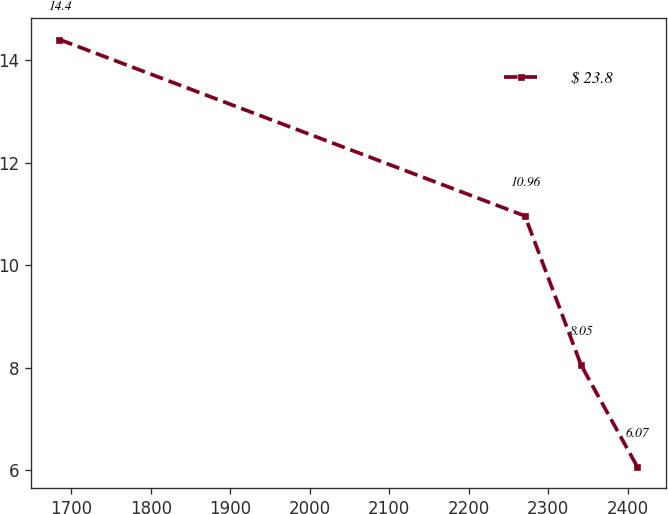Convert chart to OTSL. <chart><loc_0><loc_0><loc_500><loc_500><line_chart><ecel><fcel>$ 23.8<nl><fcel>1685.15<fcel>14.4<nl><fcel>2270.78<fcel>10.96<nl><fcel>2341.41<fcel>8.05<nl><fcel>2412.04<fcel>6.07<nl></chart> 